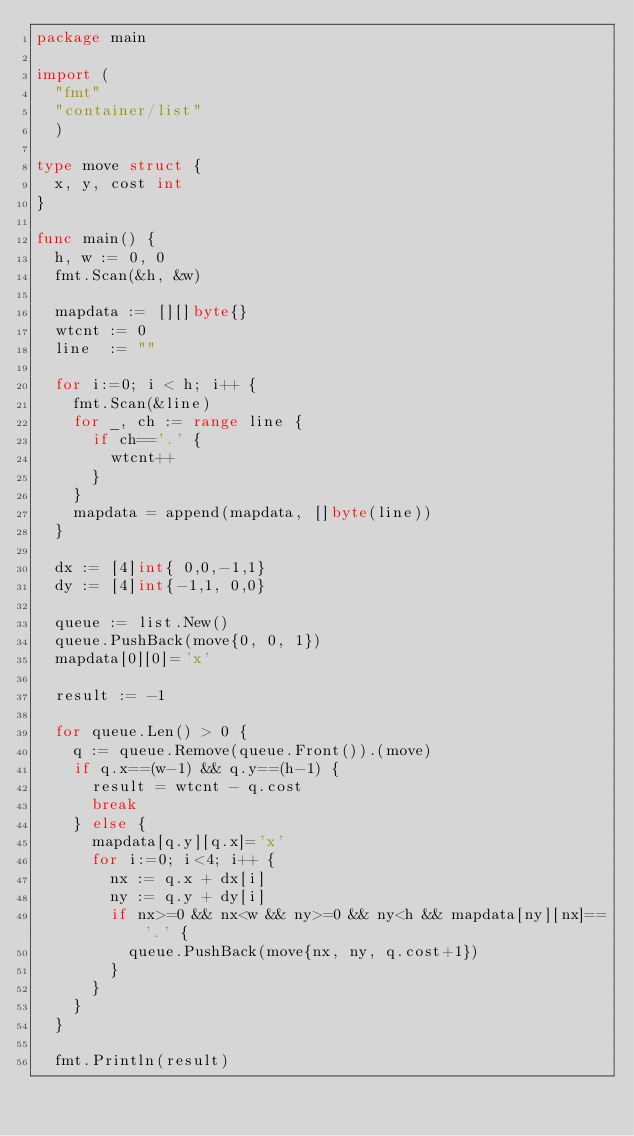Convert code to text. <code><loc_0><loc_0><loc_500><loc_500><_Go_>package main

import (
  "fmt"
  "container/list"
  )

type move struct {
  x, y, cost int
}

func main() {
  h, w := 0, 0
  fmt.Scan(&h, &w)

  mapdata := [][]byte{}
  wtcnt := 0
  line  := ""

  for i:=0; i < h; i++ {
    fmt.Scan(&line)
    for _, ch := range line {
      if ch=='.' {
        wtcnt++
      }
    }
    mapdata = append(mapdata, []byte(line))
  }

  dx := [4]int{ 0,0,-1,1}
  dy := [4]int{-1,1, 0,0}

  queue := list.New()
  queue.PushBack(move{0, 0, 1})
  mapdata[0][0]='x'

  result := -1

  for queue.Len() > 0 {
    q := queue.Remove(queue.Front()).(move)
    if q.x==(w-1) && q.y==(h-1) {
      result = wtcnt - q.cost
      break
    } else {
      mapdata[q.y][q.x]='x'
      for i:=0; i<4; i++ {
        nx := q.x + dx[i]
        ny := q.y + dy[i]
        if nx>=0 && nx<w && ny>=0 && ny<h && mapdata[ny][nx]=='.' {
          queue.PushBack(move{nx, ny, q.cost+1})
        }
      }
    }
  }

  fmt.Println(result)
</code> 